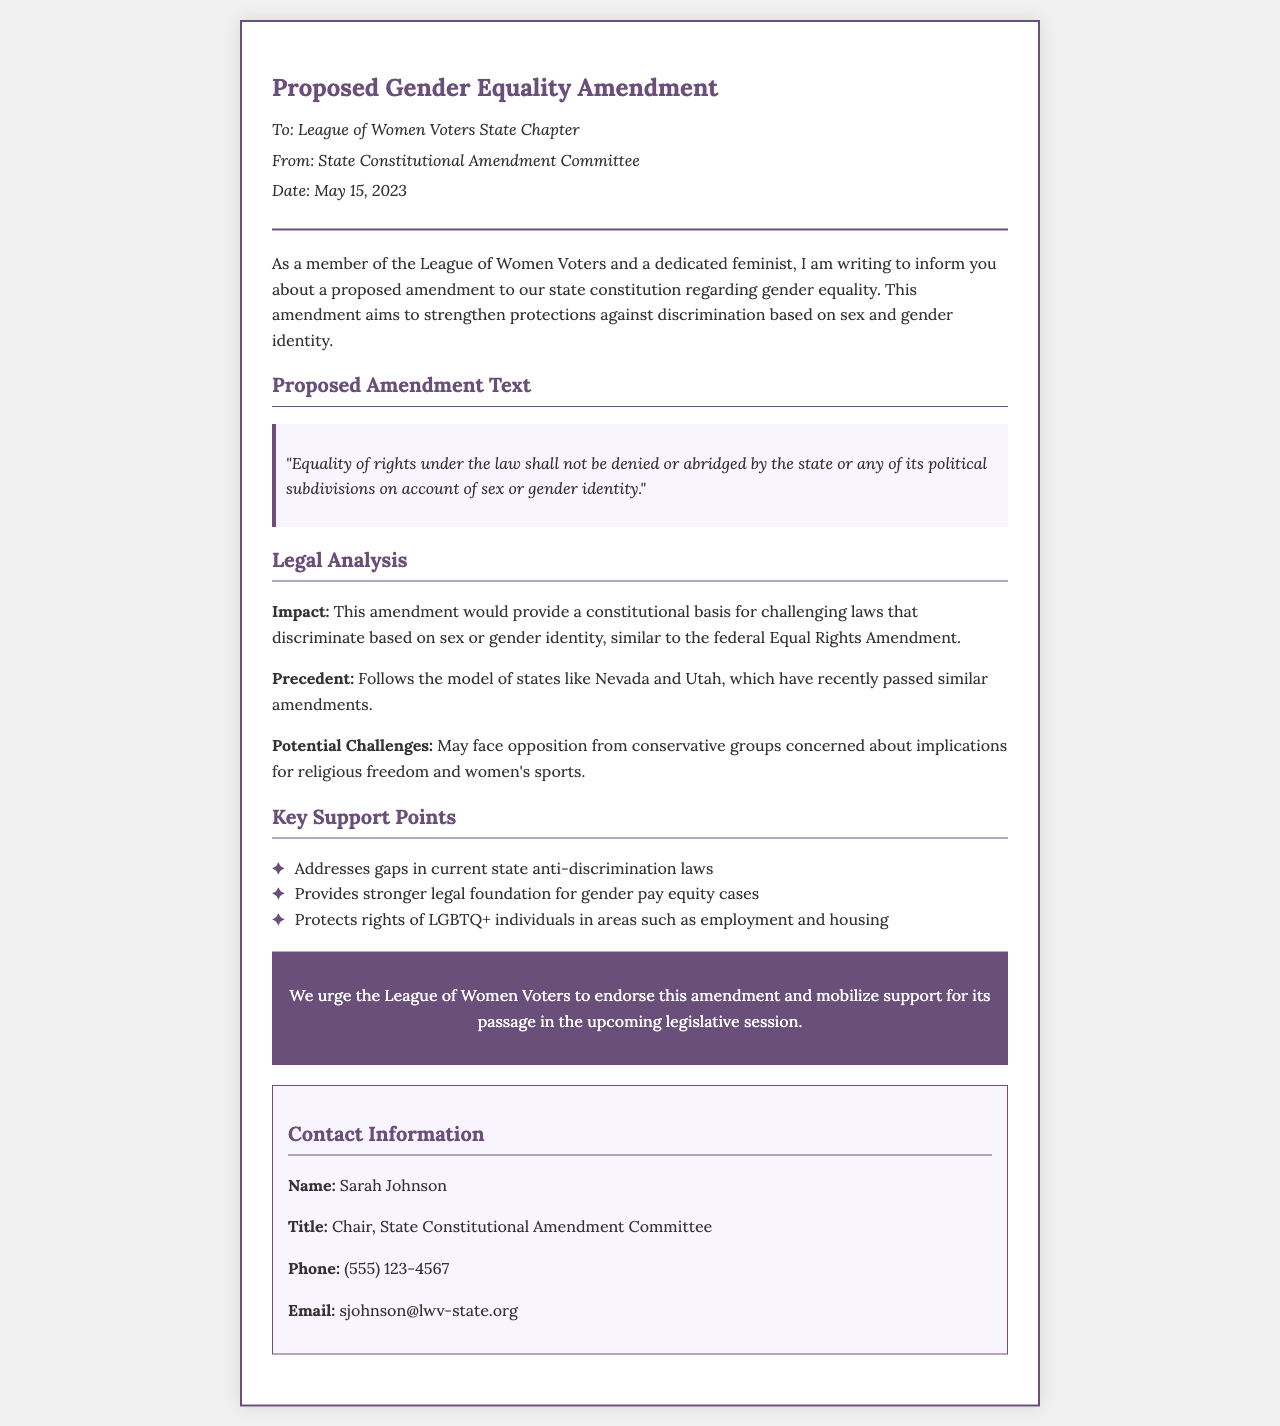What is the proposed amendment's date? The date mentioned in the document for the proposed amendment fax is May 15, 2023.
Answer: May 15, 2023 Who is the sender of the fax? The fax is sent by the State Constitutional Amendment Committee, represented by Chair Sarah Johnson.
Answer: State Constitutional Amendment Committee What rights does the proposed amendment aim to protect? The amendment specifically aims to protect equality of rights under the law regarding sex and gender identity.
Answer: Gender identity What are the potential challenges mentioned in the fax? The document states that the amendment may face opposition from conservative groups concerned about religious freedom and women's sports.
Answer: Religious freedom and women's sports What is one state that has passed a similar amendment? The fax mentions states like Nevada and Utah as examples that have passed similar amendments.
Answer: Nevada What is the primary call to action in this document? The document urges the League of Women Voters to endorse the amendment and mobilize support for its passage.
Answer: Endorse this amendment What is one impact of the proposed amendment outlined in the legal analysis? The amendment would provide a constitutional basis for challenging laws that discriminate based on sex or gender identity.
Answer: Constitutional basis What is the phone number for the contact person? The document provides Sarah Johnson's phone number as (555) 123-4567.
Answer: (555) 123-4567 